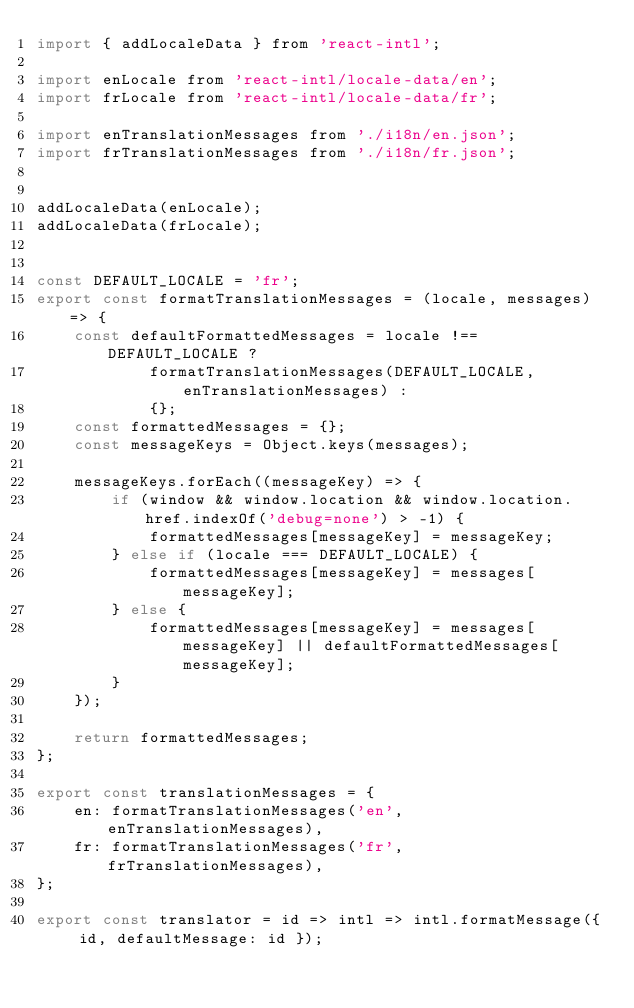Convert code to text. <code><loc_0><loc_0><loc_500><loc_500><_JavaScript_>import { addLocaleData } from 'react-intl';

import enLocale from 'react-intl/locale-data/en';
import frLocale from 'react-intl/locale-data/fr';

import enTranslationMessages from './i18n/en.json';
import frTranslationMessages from './i18n/fr.json';


addLocaleData(enLocale);
addLocaleData(frLocale);


const DEFAULT_LOCALE = 'fr';
export const formatTranslationMessages = (locale, messages) => {
    const defaultFormattedMessages = locale !== DEFAULT_LOCALE ?
            formatTranslationMessages(DEFAULT_LOCALE, enTranslationMessages) :
            {};
    const formattedMessages = {};
    const messageKeys = Object.keys(messages);

    messageKeys.forEach((messageKey) => {
        if (window && window.location && window.location.href.indexOf('debug=none') > -1) {
            formattedMessages[messageKey] = messageKey;
        } else if (locale === DEFAULT_LOCALE) {
            formattedMessages[messageKey] = messages[messageKey];
        } else {
            formattedMessages[messageKey] = messages[messageKey] || defaultFormattedMessages[messageKey];
        }
    });

    return formattedMessages;
};

export const translationMessages = {
    en: formatTranslationMessages('en', enTranslationMessages),
    fr: formatTranslationMessages('fr', frTranslationMessages),
};

export const translator = id => intl => intl.formatMessage({ id, defaultMessage: id });
</code> 